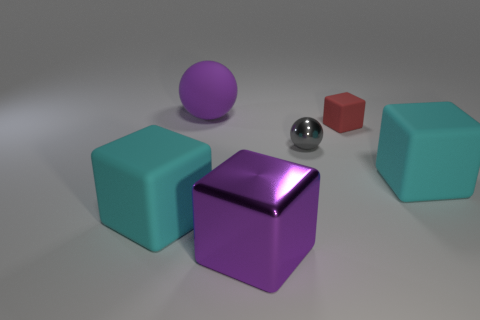Are there an equal number of big rubber spheres that are in front of the metallic block and purple objects?
Make the answer very short. No. Is there anything else that has the same size as the metallic ball?
Provide a short and direct response. Yes. There is another small thing that is the same shape as the purple shiny thing; what is it made of?
Provide a short and direct response. Rubber. There is a purple thing behind the big cyan block that is to the left of the big rubber sphere; what shape is it?
Provide a short and direct response. Sphere. Does the big cyan block that is left of the gray metal thing have the same material as the purple ball?
Provide a succinct answer. Yes. Are there an equal number of cyan rubber things that are on the left side of the large matte ball and rubber cubes to the left of the purple shiny thing?
Make the answer very short. Yes. There is a big thing that is the same color as the rubber sphere; what is it made of?
Your answer should be very brief. Metal. How many matte things are in front of the large cyan thing that is on the right side of the large purple rubber ball?
Your answer should be very brief. 1. Does the cube that is right of the red cube have the same color as the big matte cube that is left of the purple sphere?
Your response must be concise. Yes. There is a purple block that is the same size as the rubber sphere; what is its material?
Your response must be concise. Metal. 